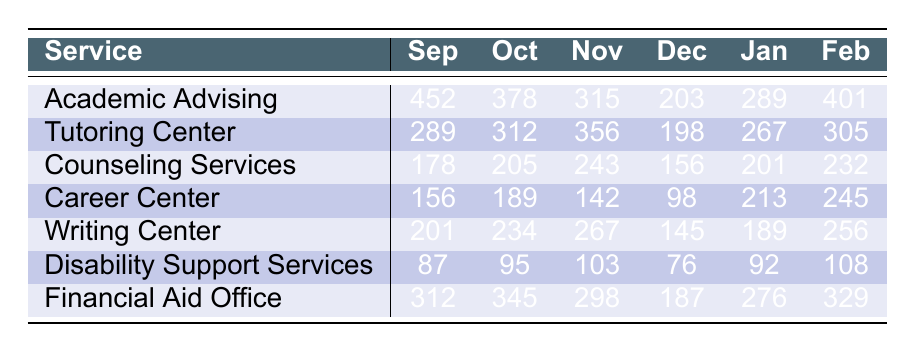What was the most used support service in September? The table shows the usage data for all services in September. The highest figure is 452 for Academic Advising, which indicates that it was the most used service during that month.
Answer: Academic Advising Which service had the least usage in January? Looking at the data for January, the least usage is 189 for Writing Center. This shows that Writing Center had the least engagement among all services in that month.
Answer: Writing Center What was the total usage of the Counseling Services from September to November? To find the total usage, we sum the numbers for Counseling Services in September (178), October (205), and November (243). The total is 178 + 205 + 243 = 626.
Answer: 626 Which month had the highest usage for the Career Center? The Career Center's usage figures are listed as 156 (Sep), 189 (Oct), 142 (Nov), 98 (Dec), 213 (Jan), and 245 (Feb). The highest figure is 245 in February, indicating that it was the month with the most engagements.
Answer: February What is the average usage of the Disability Support Services over the six months? To find the average, we sum the usage data for Disability Support Services: 87 + 95 + 103 + 76 + 92 + 108 = 561. There are 6 months, so the average is 561 / 6 ≈ 93.5.
Answer: 93.5 Did Financial Aid Office have a usage higher than 300 in every month? Examining the usage data for Financial Aid Office, we see the figures are 312, 345, 298, 187, 276, and 329. Since 298, 187, and 276 are less than 300, the answer is no.
Answer: No What was the increase in usage for Academic Advising from December to February? The usage for Academic Advising was 203 in December and 401 in February. To find the increase, we subtract December from February: 401 - 203 = 198.
Answer: 198 Which service had consistent usage across all six months? None of the services showed consistent usage since all values differ month by month when analyzed individually. The highest variance can be noted in Counseling Services and Career Center.
Answer: None Calculate the total usage for all services in October. We add the usage data for all services in October: 378 (Academic Advising) + 312 (Tutoring Center) + 205 (Counseling Services) + 189 (Career Center) + 234 (Writing Center) + 95 (Disability Support Services) + 345 (Financial Aid Office) = 1758.
Answer: 1758 In which month did the Tutoring Center show the highest usage? By looking at the usage data for the Tutoring Center, we see the figures: 289 (Sep), 312 (Oct), 356 (Nov), 198 (Dec), 267 (Jan), and 305 (Feb). The highest is 356, which occurred in November.
Answer: November 